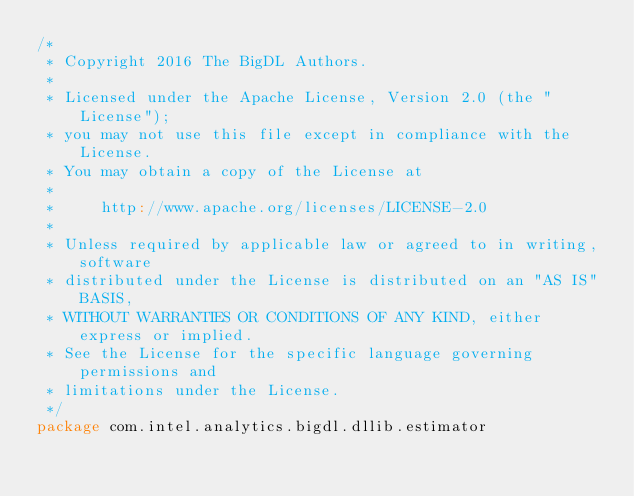<code> <loc_0><loc_0><loc_500><loc_500><_Scala_>/*
 * Copyright 2016 The BigDL Authors.
 *
 * Licensed under the Apache License, Version 2.0 (the "License");
 * you may not use this file except in compliance with the License.
 * You may obtain a copy of the License at
 *
 *     http://www.apache.org/licenses/LICENSE-2.0
 *
 * Unless required by applicable law or agreed to in writing, software
 * distributed under the License is distributed on an "AS IS" BASIS,
 * WITHOUT WARRANTIES OR CONDITIONS OF ANY KIND, either express or implied.
 * See the License for the specific language governing permissions and
 * limitations under the License.
 */
package com.intel.analytics.bigdl.dllib.estimator
</code> 